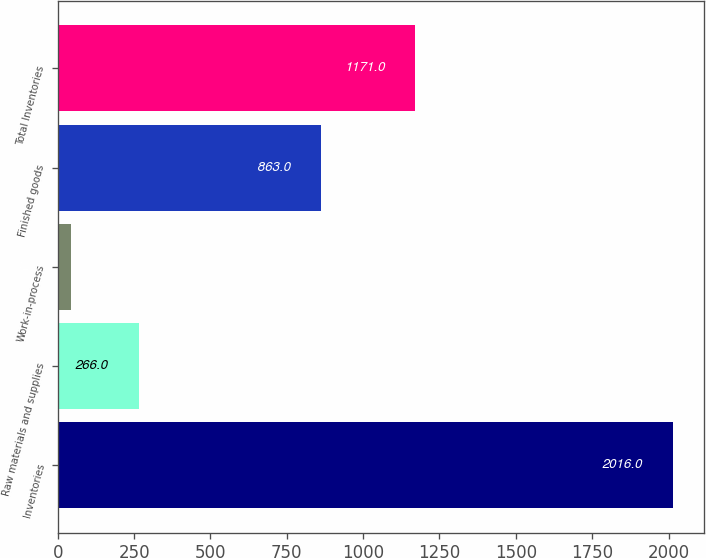<chart> <loc_0><loc_0><loc_500><loc_500><bar_chart><fcel>Inventories<fcel>Raw materials and supplies<fcel>Work-in-process<fcel>Finished goods<fcel>Total Inventories<nl><fcel>2016<fcel>266<fcel>42<fcel>863<fcel>1171<nl></chart> 